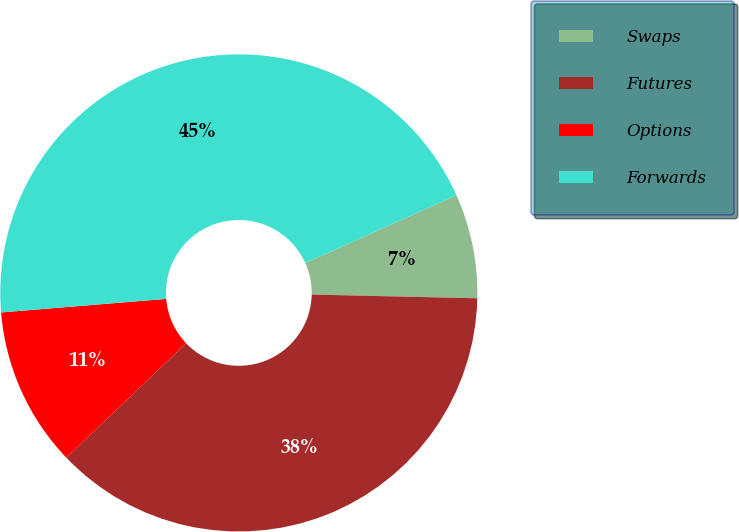<chart> <loc_0><loc_0><loc_500><loc_500><pie_chart><fcel>Swaps<fcel>Futures<fcel>Options<fcel>Forwards<nl><fcel>7.08%<fcel>37.51%<fcel>10.83%<fcel>44.59%<nl></chart> 